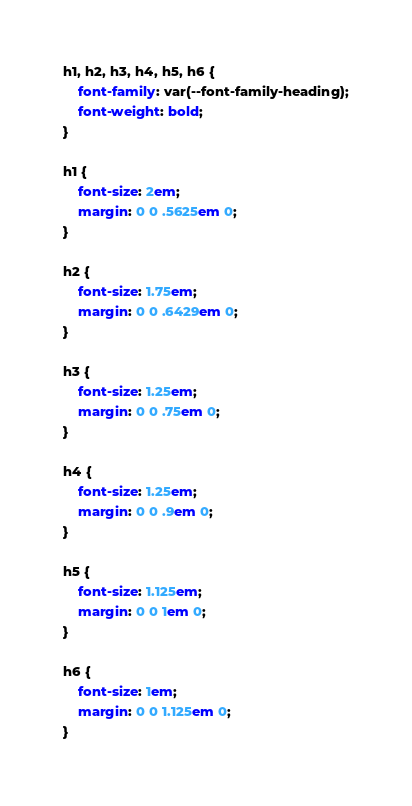Convert code to text. <code><loc_0><loc_0><loc_500><loc_500><_CSS_>h1, h2, h3, h4, h5, h6 {
	font-family: var(--font-family-heading);
	font-weight: bold;
}

h1 {
	font-size: 2em;
	margin: 0 0 .5625em 0;
}

h2 {
	font-size: 1.75em;
	margin: 0 0 .6429em 0;
}

h3 {
	font-size: 1.25em;
	margin: 0 0 .75em 0;
}

h4 {
	font-size: 1.25em;
	margin: 0 0 .9em 0;
}

h5 {
	font-size: 1.125em;
	margin: 0 0 1em 0;
}

h6 {
	font-size: 1em;
	margin: 0 0 1.125em 0;
}
</code> 